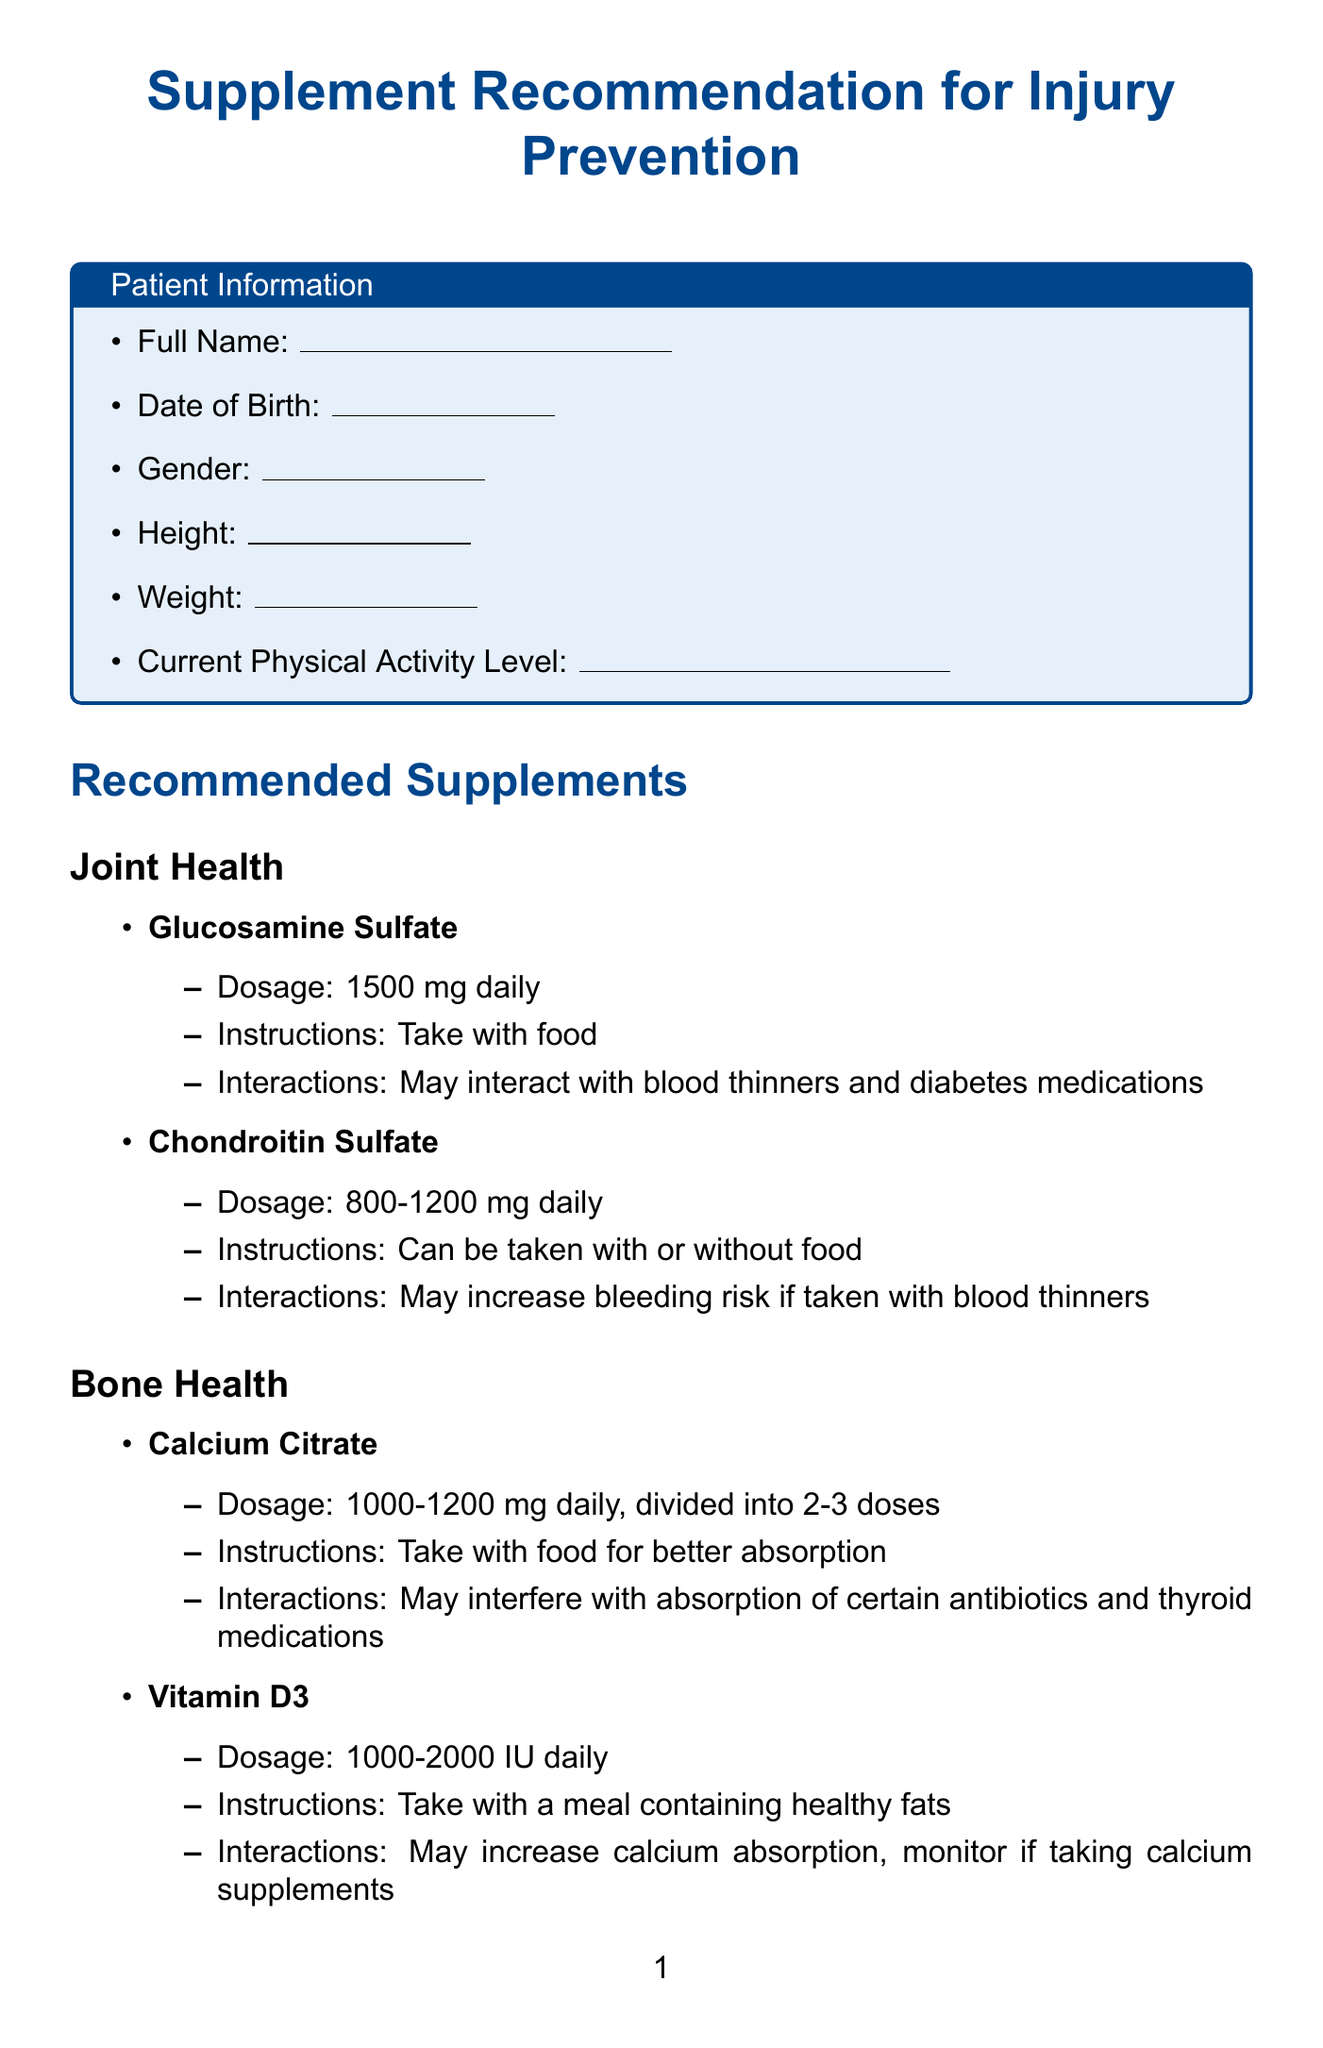What is the title of the document? The title is the main heading that describes what the document is about.
Answer: Supplement Recommendation for Injury Prevention What is the dosage for Glucosamine Sulfate? The dosage specifies the amount of the supplement recommended for use.
Answer: 1500 mg What are the potential interactions with Chondroitin Sulfate? This question asks for specific information regarding the risks of taking Chondroitin Sulfate with other medications.
Answer: May increase bleeding risk if taken with blood thinners How often should Calcium Citrate be taken? This question seeks to understand the frequency of supplementation as recommended in the document.
Answer: daily, divided into 2-3 doses What is the interaction noted for Omega-3 Fish Oil? This question looks for information regarding any known interactions that Omega-3 Fish Oil may have with other substances.
Answer: May increase bleeding risk if taken with blood thinners Which supplement is recommended for muscle recovery? This question identifies a specific category of supplements and their purpose as mentioned in the document.
Answer: Whey Protein Isolate What should be included in the patient information section? This question is focused on understanding the required information that must be collected from the patient.
Answer: Full Name, Date of Birth, Gender, Height, Weight, Current Physical Activity Level What are the additional notes concerning supplements? This question seeks to summarize the advice given about general supplement usage in the document.
Answer: Always consult with your healthcare provider before starting any new supplement regimen Who should sign the document? This question inquires about the individual responsible for recommending the supplements as indicated in the document.
Answer: Registered Dietitian 